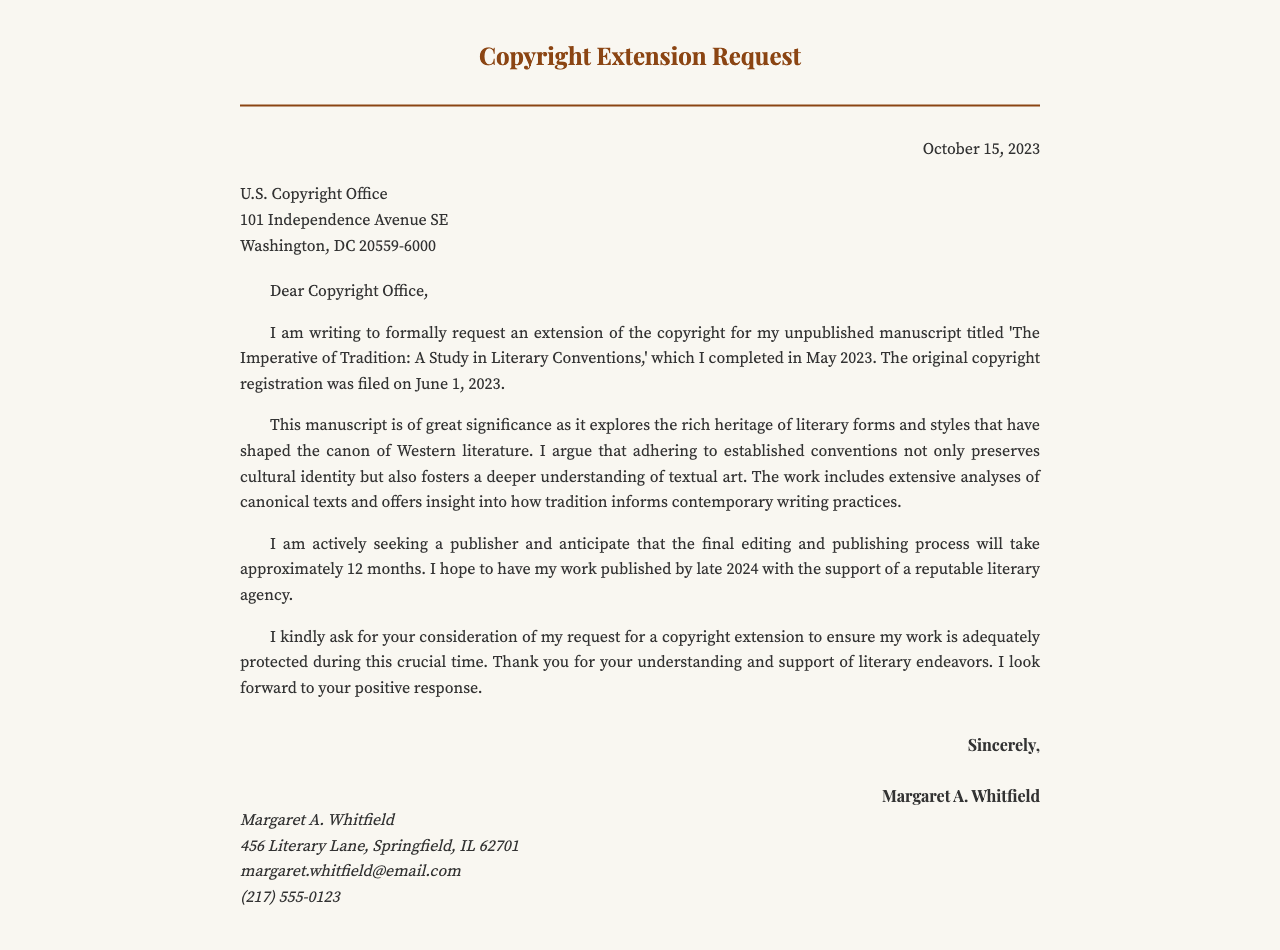What is the title of the manuscript? The title of the manuscript is mentioned in the letter as 'The Imperative of Tradition: A Study in Literary Conventions.'
Answer: The Imperative of Tradition: A Study in Literary Conventions When was the manuscript completed? The completion date of the manuscript is provided in the letter as May 2023.
Answer: May 2023 Who is the author of the letter? The author of the letter is clearly stated at the end of the document as Margaret A. Whitfield.
Answer: Margaret A. Whitfield What is the expected publication timeline for the manuscript? The publication timeline is discussed in the letter, indicating it will take approximately 12 months resulting in publication by late 2024.
Answer: Late 2024 What date was the original copyright registration filed? The letter specifies the original copyright registration date as June 1, 2023.
Answer: June 1, 2023 What is the main argument of the manuscript? The main argument, as summarized in the letter, is that adhering to established conventions preserves cultural identity and fosters understanding of textual art.
Answer: Preserves cultural identity and fosters understanding of textual art How does the author view literary conventions? The author's view on literary conventions is expressed in the letter as significant in shaping the canon of Western literature.
Answer: Significant in shaping the canon of Western literature To whom is the letter addressed? The recipient of the letter is identified as the U.S. Copyright Office in the address section.
Answer: U.S. Copyright Office What is the purpose of the request? The purpose of the request is clearly stated as asking for an extension of the copyright for the unpublished manuscript.
Answer: Extension of the copyright 